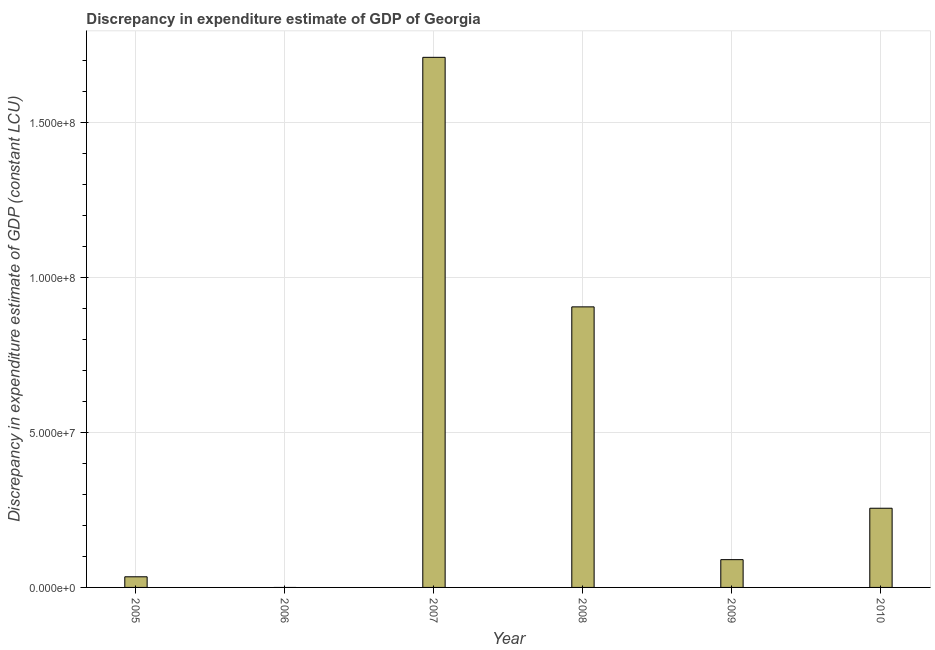Does the graph contain grids?
Your answer should be compact. Yes. What is the title of the graph?
Your response must be concise. Discrepancy in expenditure estimate of GDP of Georgia. What is the label or title of the X-axis?
Your answer should be compact. Year. What is the label or title of the Y-axis?
Offer a terse response. Discrepancy in expenditure estimate of GDP (constant LCU). What is the discrepancy in expenditure estimate of gdp in 2007?
Ensure brevity in your answer.  1.71e+08. Across all years, what is the maximum discrepancy in expenditure estimate of gdp?
Give a very brief answer. 1.71e+08. In which year was the discrepancy in expenditure estimate of gdp maximum?
Ensure brevity in your answer.  2007. What is the sum of the discrepancy in expenditure estimate of gdp?
Your response must be concise. 2.99e+08. What is the difference between the discrepancy in expenditure estimate of gdp in 2009 and 2010?
Your response must be concise. -1.66e+07. What is the average discrepancy in expenditure estimate of gdp per year?
Ensure brevity in your answer.  4.99e+07. What is the median discrepancy in expenditure estimate of gdp?
Offer a very short reply. 1.72e+07. What is the ratio of the discrepancy in expenditure estimate of gdp in 2008 to that in 2010?
Give a very brief answer. 3.54. Is the difference between the discrepancy in expenditure estimate of gdp in 2008 and 2009 greater than the difference between any two years?
Ensure brevity in your answer.  No. What is the difference between the highest and the second highest discrepancy in expenditure estimate of gdp?
Give a very brief answer. 8.05e+07. What is the difference between the highest and the lowest discrepancy in expenditure estimate of gdp?
Offer a terse response. 1.71e+08. What is the difference between two consecutive major ticks on the Y-axis?
Your answer should be very brief. 5.00e+07. Are the values on the major ticks of Y-axis written in scientific E-notation?
Make the answer very short. Yes. What is the Discrepancy in expenditure estimate of GDP (constant LCU) of 2005?
Offer a very short reply. 3.43e+06. What is the Discrepancy in expenditure estimate of GDP (constant LCU) of 2006?
Make the answer very short. 0. What is the Discrepancy in expenditure estimate of GDP (constant LCU) in 2007?
Ensure brevity in your answer.  1.71e+08. What is the Discrepancy in expenditure estimate of GDP (constant LCU) of 2008?
Make the answer very short. 9.05e+07. What is the Discrepancy in expenditure estimate of GDP (constant LCU) of 2009?
Your answer should be compact. 8.96e+06. What is the Discrepancy in expenditure estimate of GDP (constant LCU) of 2010?
Make the answer very short. 2.55e+07. What is the difference between the Discrepancy in expenditure estimate of GDP (constant LCU) in 2005 and 2007?
Your response must be concise. -1.67e+08. What is the difference between the Discrepancy in expenditure estimate of GDP (constant LCU) in 2005 and 2008?
Keep it short and to the point. -8.70e+07. What is the difference between the Discrepancy in expenditure estimate of GDP (constant LCU) in 2005 and 2009?
Provide a succinct answer. -5.53e+06. What is the difference between the Discrepancy in expenditure estimate of GDP (constant LCU) in 2005 and 2010?
Offer a terse response. -2.21e+07. What is the difference between the Discrepancy in expenditure estimate of GDP (constant LCU) in 2007 and 2008?
Your answer should be very brief. 8.05e+07. What is the difference between the Discrepancy in expenditure estimate of GDP (constant LCU) in 2007 and 2009?
Give a very brief answer. 1.62e+08. What is the difference between the Discrepancy in expenditure estimate of GDP (constant LCU) in 2007 and 2010?
Give a very brief answer. 1.45e+08. What is the difference between the Discrepancy in expenditure estimate of GDP (constant LCU) in 2008 and 2009?
Offer a very short reply. 8.15e+07. What is the difference between the Discrepancy in expenditure estimate of GDP (constant LCU) in 2008 and 2010?
Your response must be concise. 6.49e+07. What is the difference between the Discrepancy in expenditure estimate of GDP (constant LCU) in 2009 and 2010?
Provide a succinct answer. -1.66e+07. What is the ratio of the Discrepancy in expenditure estimate of GDP (constant LCU) in 2005 to that in 2008?
Keep it short and to the point. 0.04. What is the ratio of the Discrepancy in expenditure estimate of GDP (constant LCU) in 2005 to that in 2009?
Your answer should be compact. 0.38. What is the ratio of the Discrepancy in expenditure estimate of GDP (constant LCU) in 2005 to that in 2010?
Your response must be concise. 0.13. What is the ratio of the Discrepancy in expenditure estimate of GDP (constant LCU) in 2007 to that in 2008?
Give a very brief answer. 1.89. What is the ratio of the Discrepancy in expenditure estimate of GDP (constant LCU) in 2007 to that in 2009?
Your response must be concise. 19.08. What is the ratio of the Discrepancy in expenditure estimate of GDP (constant LCU) in 2007 to that in 2010?
Keep it short and to the point. 6.69. What is the ratio of the Discrepancy in expenditure estimate of GDP (constant LCU) in 2008 to that in 2009?
Make the answer very short. 10.1. What is the ratio of the Discrepancy in expenditure estimate of GDP (constant LCU) in 2008 to that in 2010?
Give a very brief answer. 3.54. What is the ratio of the Discrepancy in expenditure estimate of GDP (constant LCU) in 2009 to that in 2010?
Provide a succinct answer. 0.35. 